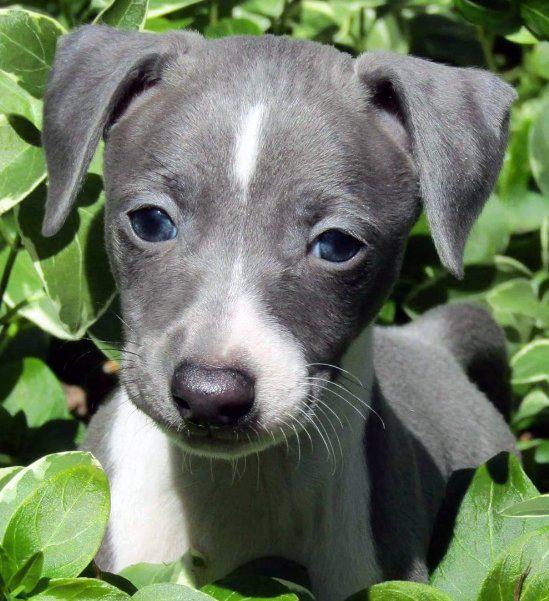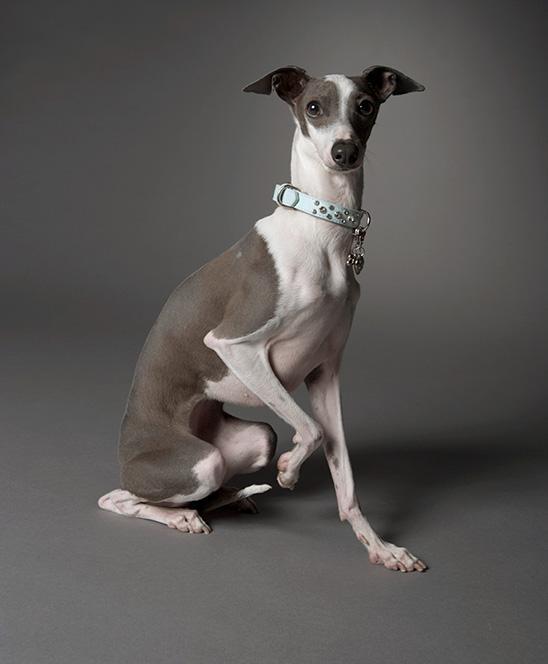The first image is the image on the left, the second image is the image on the right. Assess this claim about the two images: "Each image contains exactly one dog, and the dog on the left is dark charcoal gray with white markings.". Correct or not? Answer yes or no. Yes. The first image is the image on the left, the second image is the image on the right. Assess this claim about the two images: "The dog on the left is posing for the picture outside on a sunny day.". Correct or not? Answer yes or no. Yes. 